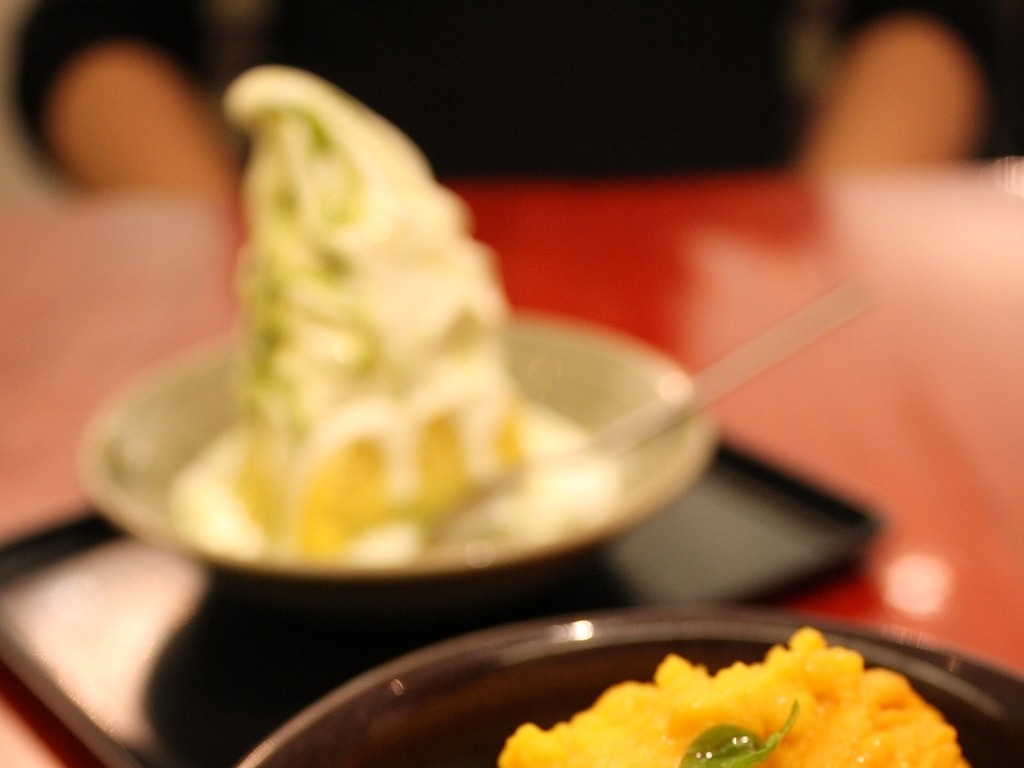Can you describe the setting or atmosphere suggested by this image? The image conveys an intimate and casual dining atmosphere, likely in a cafe or dessert shop, where patrons can enjoy sweet treats. The soft lighting and blurred background suggest a relaxed and comfortable space focused on the culinary experience. 